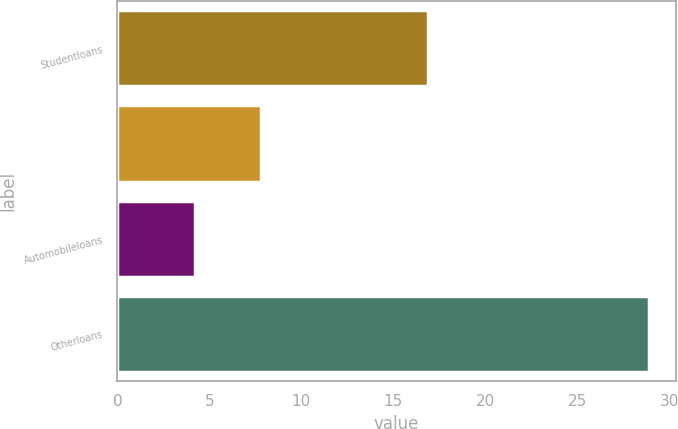Convert chart to OTSL. <chart><loc_0><loc_0><loc_500><loc_500><bar_chart><fcel>Studentloans<fcel>Unnamed: 1<fcel>Automobileloans<fcel>Otherloans<nl><fcel>16.9<fcel>7.8<fcel>4.2<fcel>28.9<nl></chart> 